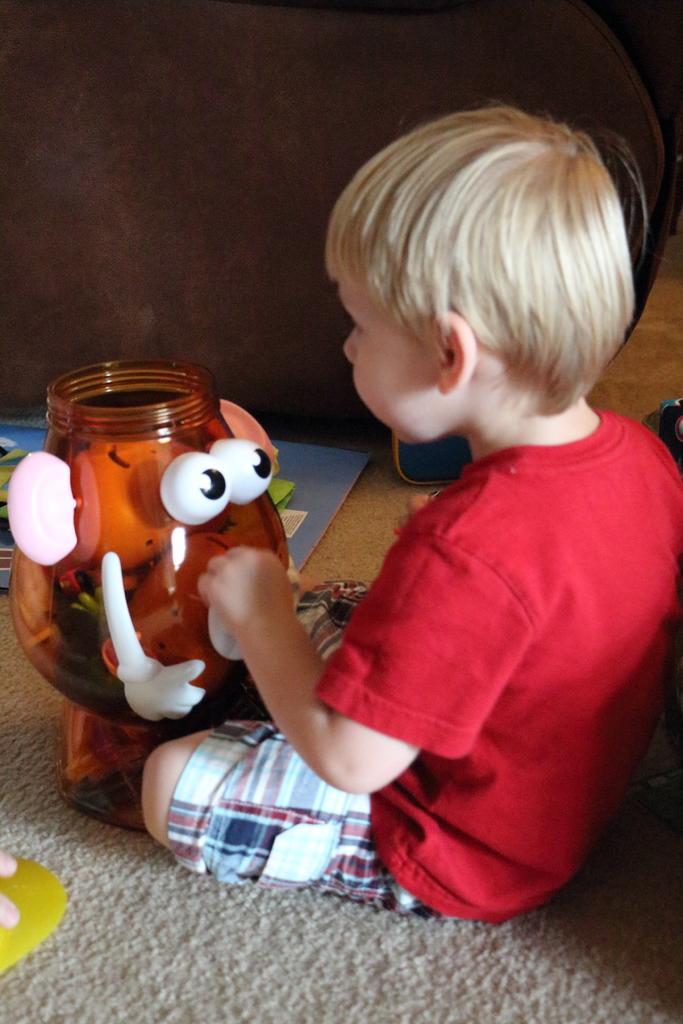Please provide a concise description of this image. In this image boy is sitting on the floor. In front of him there are toys. 